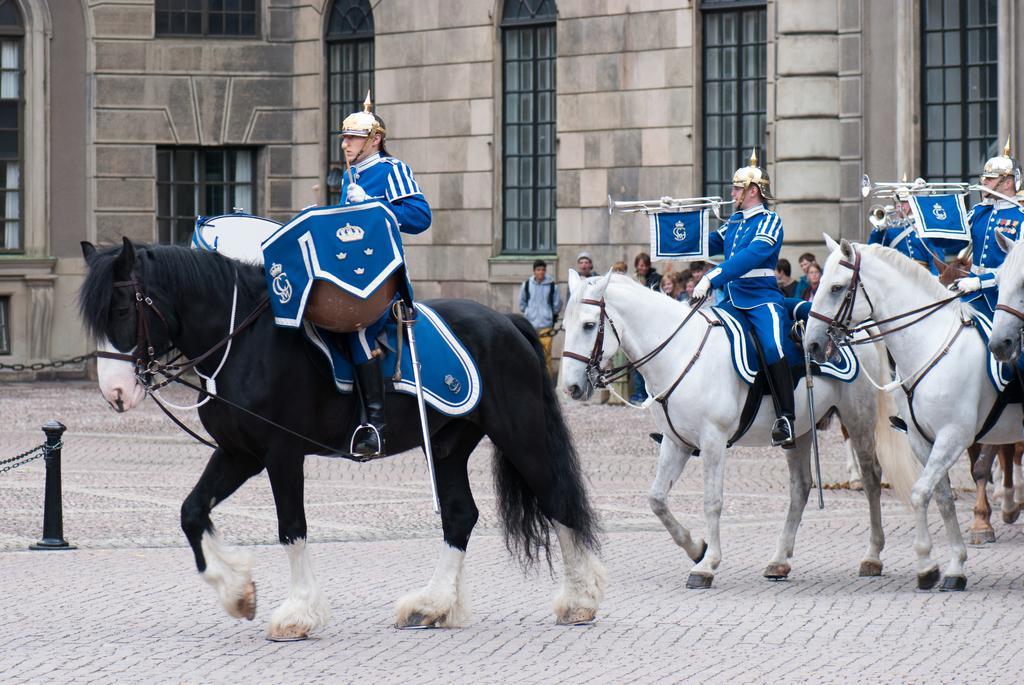Can you describe this image briefly? In this picture we can see a few people sitting on the horses. We can see a pole and a few chains on the left side. There are a few people playing musical instruments on the right side. We can see a few people at the back. There is a building in the background. 